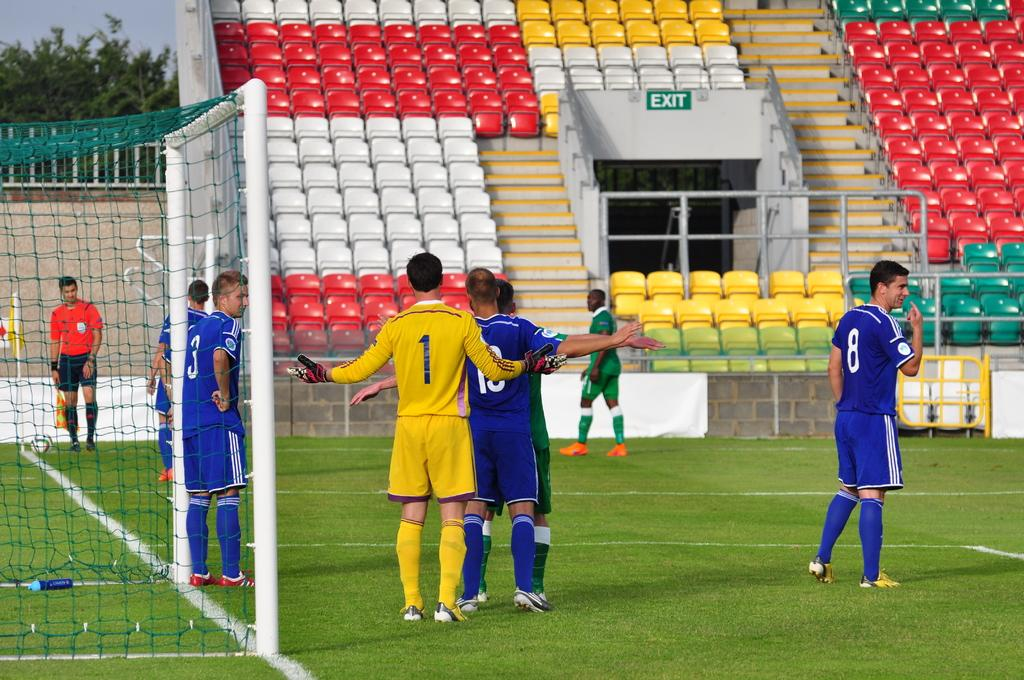<image>
Present a compact description of the photo's key features. Soccer players are near a goal, player wearing jersey number 1 holding his arms out. 